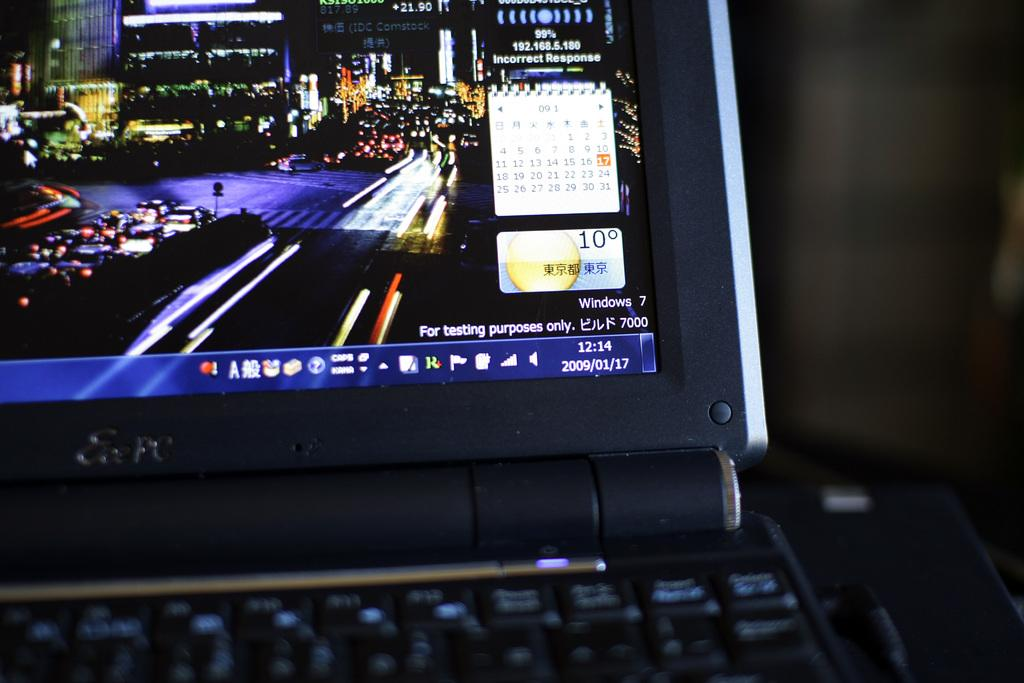<image>
Describe the image concisely. A calendar on a laptop display is marked 9/17. 